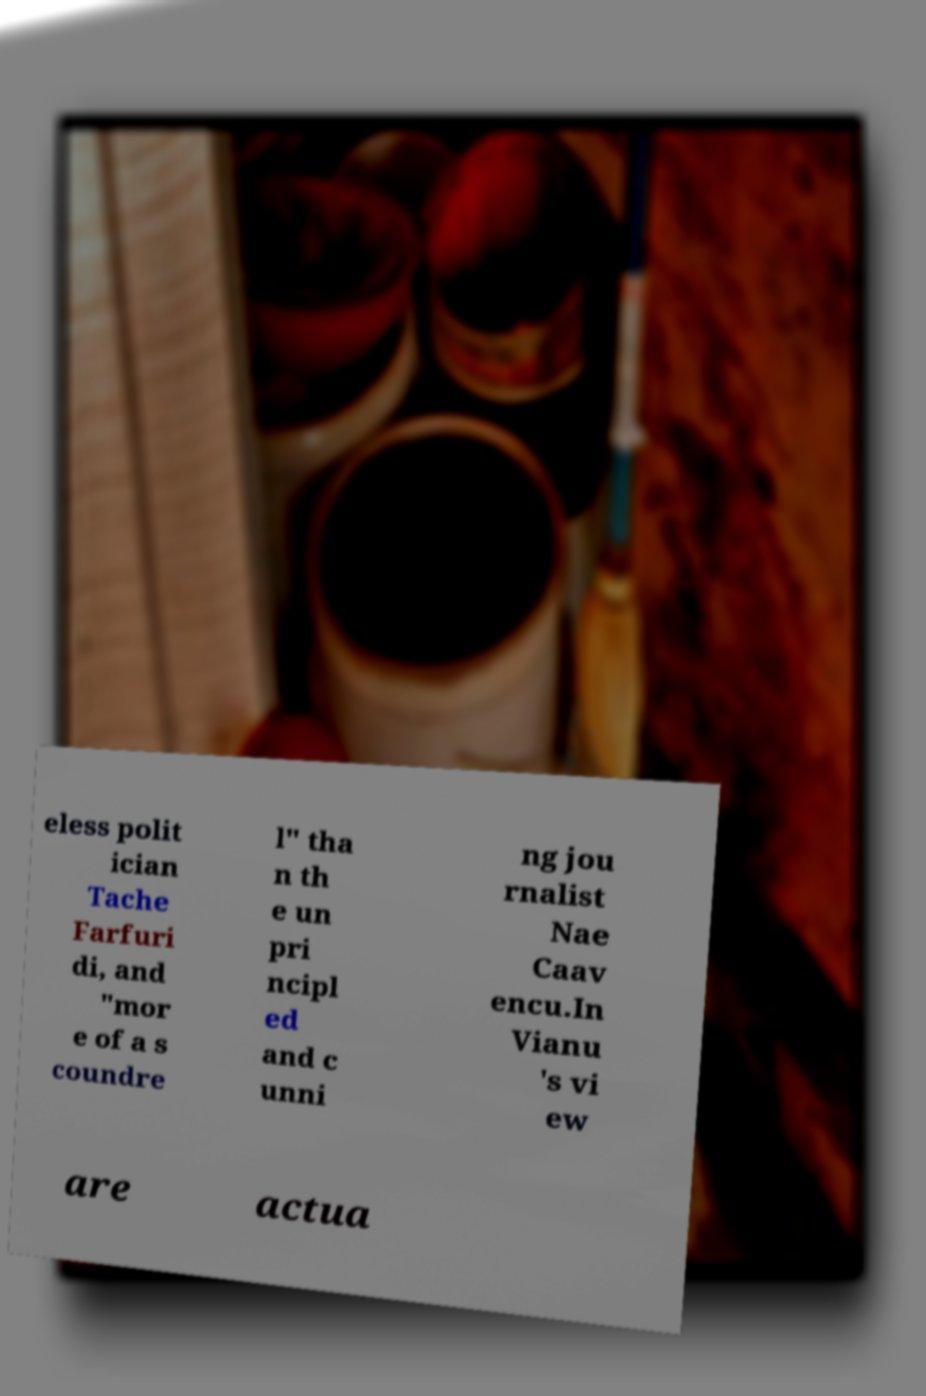Please read and relay the text visible in this image. What does it say? eless polit ician Tache Farfuri di, and "mor e of a s coundre l" tha n th e un pri ncipl ed and c unni ng jou rnalist Nae Caav encu.In Vianu 's vi ew are actua 